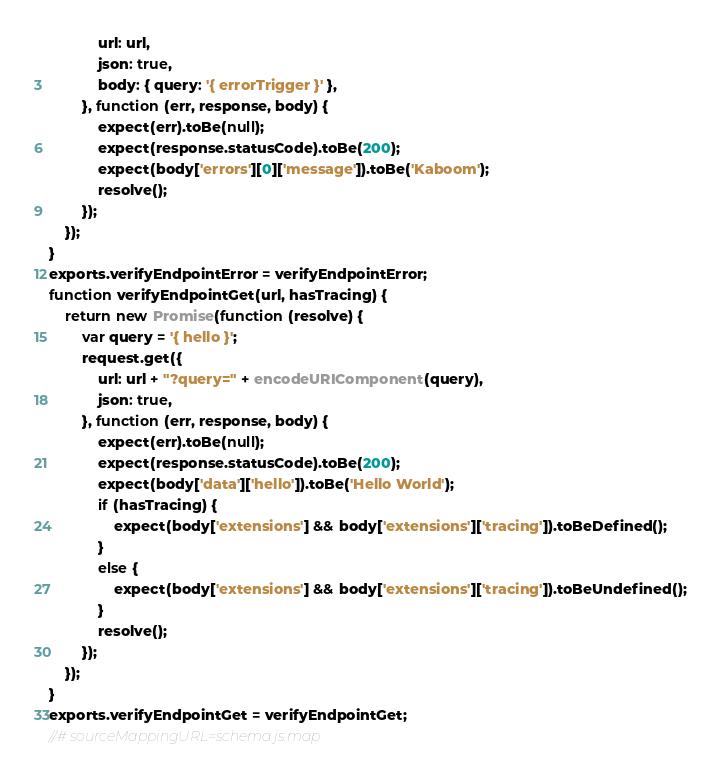<code> <loc_0><loc_0><loc_500><loc_500><_JavaScript_>            url: url,
            json: true,
            body: { query: '{ errorTrigger }' },
        }, function (err, response, body) {
            expect(err).toBe(null);
            expect(response.statusCode).toBe(200);
            expect(body['errors'][0]['message']).toBe('Kaboom');
            resolve();
        });
    });
}
exports.verifyEndpointError = verifyEndpointError;
function verifyEndpointGet(url, hasTracing) {
    return new Promise(function (resolve) {
        var query = '{ hello }';
        request.get({
            url: url + "?query=" + encodeURIComponent(query),
            json: true,
        }, function (err, response, body) {
            expect(err).toBe(null);
            expect(response.statusCode).toBe(200);
            expect(body['data']['hello']).toBe('Hello World');
            if (hasTracing) {
                expect(body['extensions'] && body['extensions']['tracing']).toBeDefined();
            }
            else {
                expect(body['extensions'] && body['extensions']['tracing']).toBeUndefined();
            }
            resolve();
        });
    });
}
exports.verifyEndpointGet = verifyEndpointGet;
//# sourceMappingURL=schema.js.map</code> 